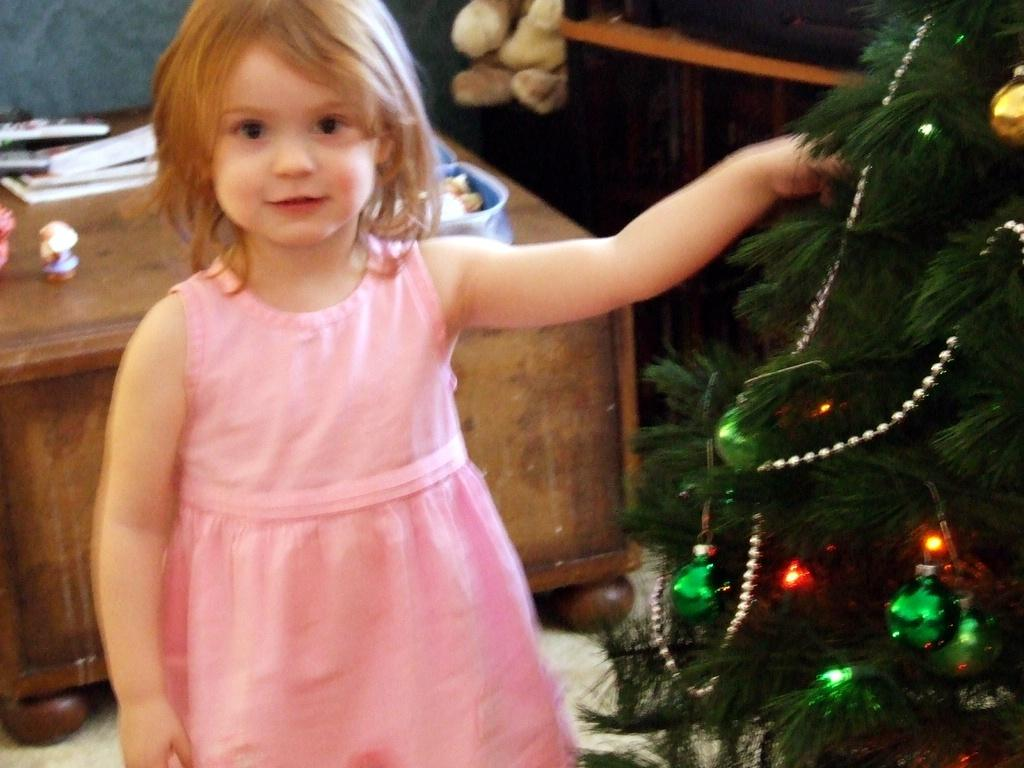Who is the main subject in the image? There is a girl standing in the image. What is the holiday-themed object in the image? There is a Christmas tree in the image. Where is the Christmas tree located in relation to the girl? The Christmas tree is to the side of the girl. What can be seen in the background of the image? There is a table with objects in the background of the image. What type of alarm can be heard going off in the image? There is no alarm present or audible in the image. What advice is the girl giving to the Christmas tree in the image? There is no interaction or dialogue between the girl and the Christmas tree in the image. 